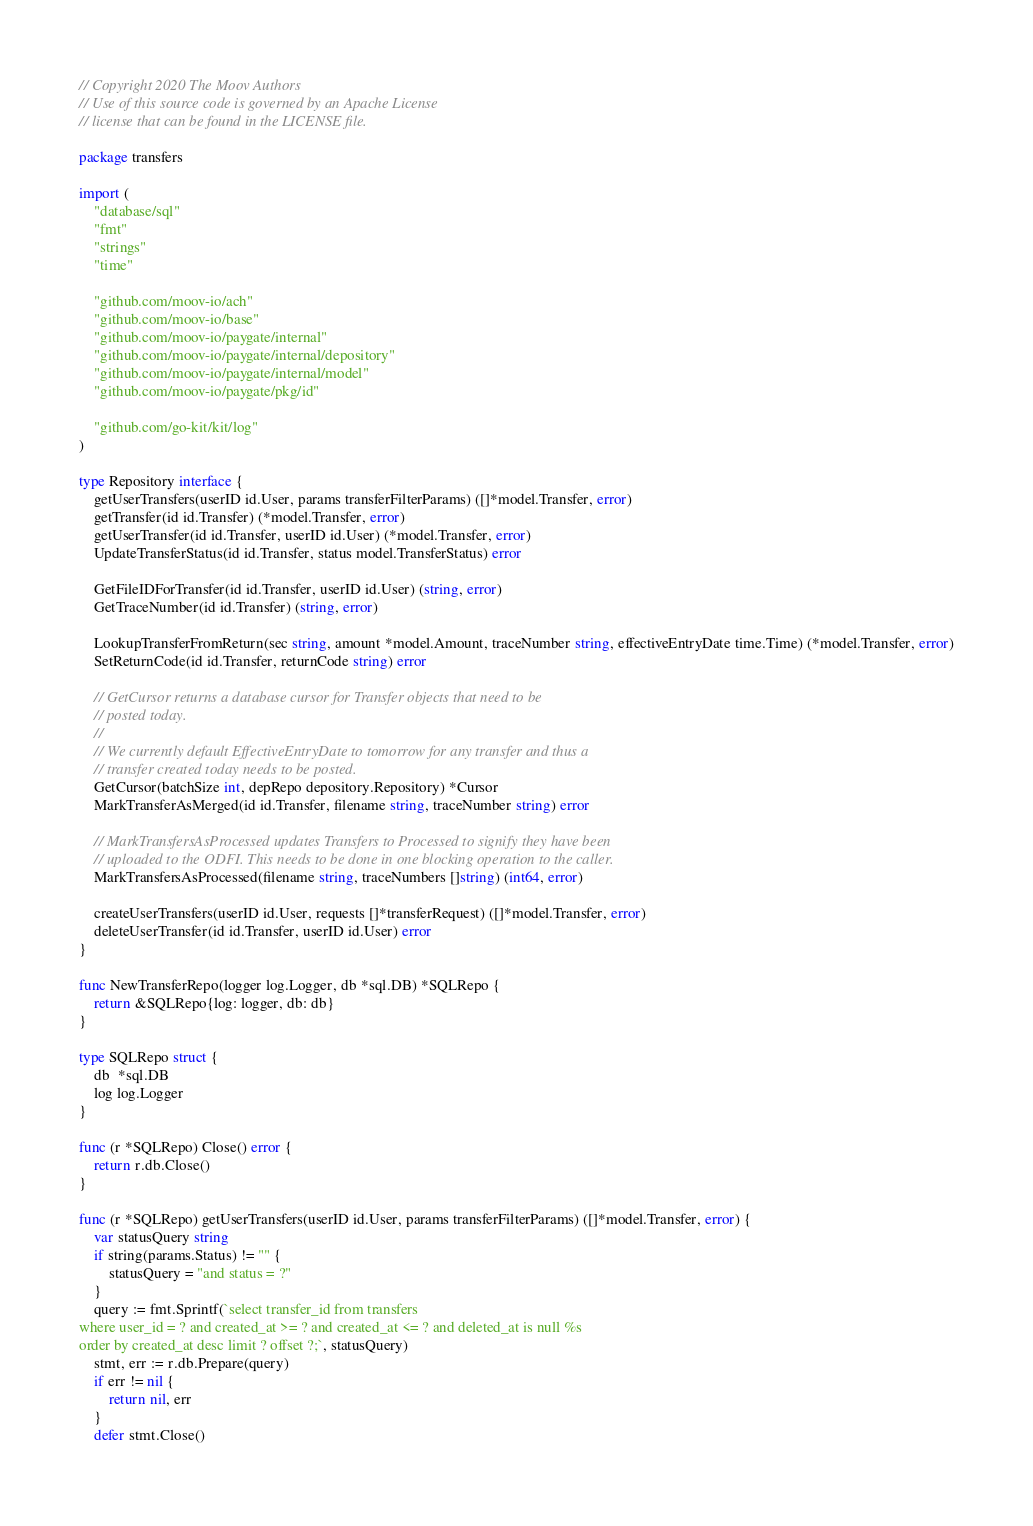<code> <loc_0><loc_0><loc_500><loc_500><_Go_>// Copyright 2020 The Moov Authors
// Use of this source code is governed by an Apache License
// license that can be found in the LICENSE file.

package transfers

import (
	"database/sql"
	"fmt"
	"strings"
	"time"

	"github.com/moov-io/ach"
	"github.com/moov-io/base"
	"github.com/moov-io/paygate/internal"
	"github.com/moov-io/paygate/internal/depository"
	"github.com/moov-io/paygate/internal/model"
	"github.com/moov-io/paygate/pkg/id"

	"github.com/go-kit/kit/log"
)

type Repository interface {
	getUserTransfers(userID id.User, params transferFilterParams) ([]*model.Transfer, error)
	getTransfer(id id.Transfer) (*model.Transfer, error)
	getUserTransfer(id id.Transfer, userID id.User) (*model.Transfer, error)
	UpdateTransferStatus(id id.Transfer, status model.TransferStatus) error

	GetFileIDForTransfer(id id.Transfer, userID id.User) (string, error)
	GetTraceNumber(id id.Transfer) (string, error)

	LookupTransferFromReturn(sec string, amount *model.Amount, traceNumber string, effectiveEntryDate time.Time) (*model.Transfer, error)
	SetReturnCode(id id.Transfer, returnCode string) error

	// GetCursor returns a database cursor for Transfer objects that need to be
	// posted today.
	//
	// We currently default EffectiveEntryDate to tomorrow for any transfer and thus a
	// transfer created today needs to be posted.
	GetCursor(batchSize int, depRepo depository.Repository) *Cursor
	MarkTransferAsMerged(id id.Transfer, filename string, traceNumber string) error

	// MarkTransfersAsProcessed updates Transfers to Processed to signify they have been
	// uploaded to the ODFI. This needs to be done in one blocking operation to the caller.
	MarkTransfersAsProcessed(filename string, traceNumbers []string) (int64, error)

	createUserTransfers(userID id.User, requests []*transferRequest) ([]*model.Transfer, error)
	deleteUserTransfer(id id.Transfer, userID id.User) error
}

func NewTransferRepo(logger log.Logger, db *sql.DB) *SQLRepo {
	return &SQLRepo{log: logger, db: db}
}

type SQLRepo struct {
	db  *sql.DB
	log log.Logger
}

func (r *SQLRepo) Close() error {
	return r.db.Close()
}

func (r *SQLRepo) getUserTransfers(userID id.User, params transferFilterParams) ([]*model.Transfer, error) {
	var statusQuery string
	if string(params.Status) != "" {
		statusQuery = "and status = ?"
	}
	query := fmt.Sprintf(`select transfer_id from transfers
where user_id = ? and created_at >= ? and created_at <= ? and deleted_at is null %s
order by created_at desc limit ? offset ?;`, statusQuery)
	stmt, err := r.db.Prepare(query)
	if err != nil {
		return nil, err
	}
	defer stmt.Close()
</code> 